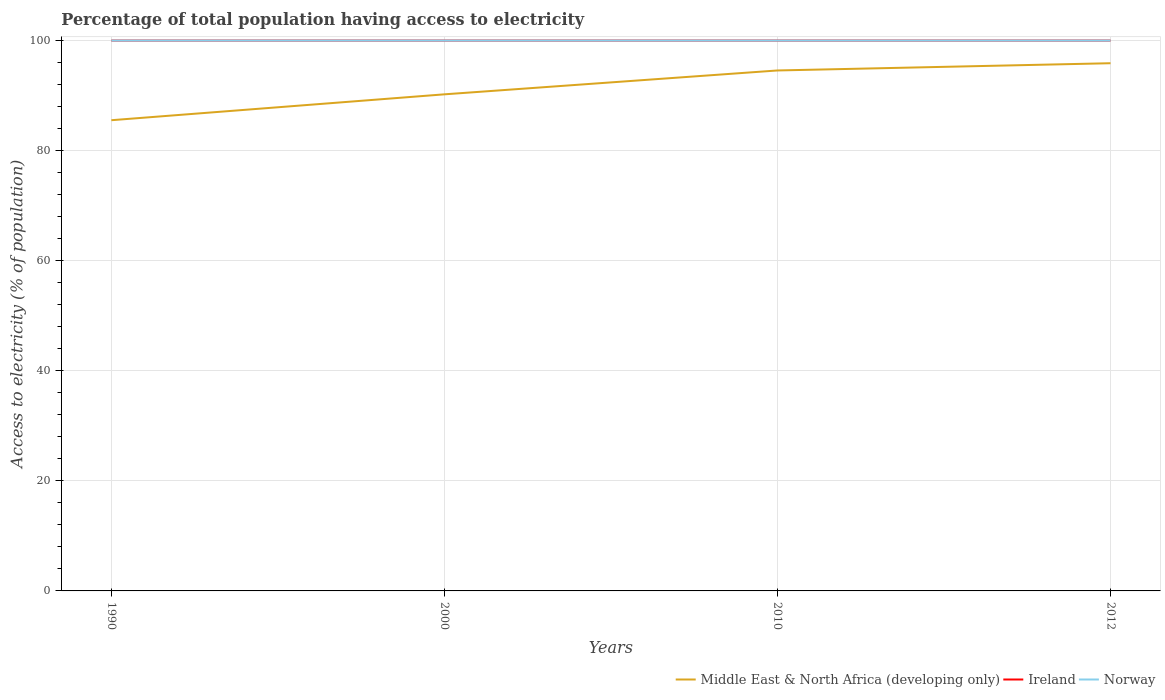How many different coloured lines are there?
Your response must be concise. 3. Does the line corresponding to Norway intersect with the line corresponding to Middle East & North Africa (developing only)?
Provide a short and direct response. No. Across all years, what is the maximum percentage of population that have access to electricity in Middle East & North Africa (developing only)?
Keep it short and to the point. 85.53. How many lines are there?
Your response must be concise. 3. What is the difference between two consecutive major ticks on the Y-axis?
Give a very brief answer. 20. Does the graph contain any zero values?
Your answer should be very brief. No. Where does the legend appear in the graph?
Your answer should be compact. Bottom right. How many legend labels are there?
Give a very brief answer. 3. How are the legend labels stacked?
Give a very brief answer. Horizontal. What is the title of the graph?
Give a very brief answer. Percentage of total population having access to electricity. What is the label or title of the Y-axis?
Offer a terse response. Access to electricity (% of population). What is the Access to electricity (% of population) of Middle East & North Africa (developing only) in 1990?
Provide a short and direct response. 85.53. What is the Access to electricity (% of population) in Norway in 1990?
Make the answer very short. 100. What is the Access to electricity (% of population) of Middle East & North Africa (developing only) in 2000?
Offer a very short reply. 90.23. What is the Access to electricity (% of population) in Ireland in 2000?
Offer a very short reply. 100. What is the Access to electricity (% of population) of Norway in 2000?
Make the answer very short. 100. What is the Access to electricity (% of population) in Middle East & North Africa (developing only) in 2010?
Provide a short and direct response. 94.57. What is the Access to electricity (% of population) in Norway in 2010?
Provide a short and direct response. 100. What is the Access to electricity (% of population) of Middle East & North Africa (developing only) in 2012?
Ensure brevity in your answer.  95.88. What is the Access to electricity (% of population) in Norway in 2012?
Provide a short and direct response. 100. Across all years, what is the maximum Access to electricity (% of population) in Middle East & North Africa (developing only)?
Your response must be concise. 95.88. Across all years, what is the minimum Access to electricity (% of population) of Middle East & North Africa (developing only)?
Offer a terse response. 85.53. What is the total Access to electricity (% of population) of Middle East & North Africa (developing only) in the graph?
Your response must be concise. 366.21. What is the total Access to electricity (% of population) of Ireland in the graph?
Give a very brief answer. 400. What is the total Access to electricity (% of population) of Norway in the graph?
Keep it short and to the point. 400. What is the difference between the Access to electricity (% of population) in Middle East & North Africa (developing only) in 1990 and that in 2000?
Provide a short and direct response. -4.7. What is the difference between the Access to electricity (% of population) in Norway in 1990 and that in 2000?
Your response must be concise. 0. What is the difference between the Access to electricity (% of population) of Middle East & North Africa (developing only) in 1990 and that in 2010?
Your response must be concise. -9.04. What is the difference between the Access to electricity (% of population) in Norway in 1990 and that in 2010?
Provide a short and direct response. 0. What is the difference between the Access to electricity (% of population) of Middle East & North Africa (developing only) in 1990 and that in 2012?
Your response must be concise. -10.36. What is the difference between the Access to electricity (% of population) in Middle East & North Africa (developing only) in 2000 and that in 2010?
Offer a very short reply. -4.34. What is the difference between the Access to electricity (% of population) of Ireland in 2000 and that in 2010?
Make the answer very short. 0. What is the difference between the Access to electricity (% of population) in Middle East & North Africa (developing only) in 2000 and that in 2012?
Your answer should be compact. -5.65. What is the difference between the Access to electricity (% of population) in Middle East & North Africa (developing only) in 2010 and that in 2012?
Offer a very short reply. -1.32. What is the difference between the Access to electricity (% of population) in Ireland in 2010 and that in 2012?
Your answer should be very brief. 0. What is the difference between the Access to electricity (% of population) in Middle East & North Africa (developing only) in 1990 and the Access to electricity (% of population) in Ireland in 2000?
Your answer should be compact. -14.47. What is the difference between the Access to electricity (% of population) of Middle East & North Africa (developing only) in 1990 and the Access to electricity (% of population) of Norway in 2000?
Keep it short and to the point. -14.47. What is the difference between the Access to electricity (% of population) of Middle East & North Africa (developing only) in 1990 and the Access to electricity (% of population) of Ireland in 2010?
Your answer should be very brief. -14.47. What is the difference between the Access to electricity (% of population) of Middle East & North Africa (developing only) in 1990 and the Access to electricity (% of population) of Norway in 2010?
Provide a short and direct response. -14.47. What is the difference between the Access to electricity (% of population) of Middle East & North Africa (developing only) in 1990 and the Access to electricity (% of population) of Ireland in 2012?
Your answer should be very brief. -14.47. What is the difference between the Access to electricity (% of population) of Middle East & North Africa (developing only) in 1990 and the Access to electricity (% of population) of Norway in 2012?
Make the answer very short. -14.47. What is the difference between the Access to electricity (% of population) in Middle East & North Africa (developing only) in 2000 and the Access to electricity (% of population) in Ireland in 2010?
Offer a terse response. -9.77. What is the difference between the Access to electricity (% of population) of Middle East & North Africa (developing only) in 2000 and the Access to electricity (% of population) of Norway in 2010?
Your answer should be compact. -9.77. What is the difference between the Access to electricity (% of population) in Ireland in 2000 and the Access to electricity (% of population) in Norway in 2010?
Ensure brevity in your answer.  0. What is the difference between the Access to electricity (% of population) of Middle East & North Africa (developing only) in 2000 and the Access to electricity (% of population) of Ireland in 2012?
Provide a short and direct response. -9.77. What is the difference between the Access to electricity (% of population) of Middle East & North Africa (developing only) in 2000 and the Access to electricity (% of population) of Norway in 2012?
Offer a terse response. -9.77. What is the difference between the Access to electricity (% of population) of Middle East & North Africa (developing only) in 2010 and the Access to electricity (% of population) of Ireland in 2012?
Provide a succinct answer. -5.43. What is the difference between the Access to electricity (% of population) in Middle East & North Africa (developing only) in 2010 and the Access to electricity (% of population) in Norway in 2012?
Make the answer very short. -5.43. What is the difference between the Access to electricity (% of population) in Ireland in 2010 and the Access to electricity (% of population) in Norway in 2012?
Ensure brevity in your answer.  0. What is the average Access to electricity (% of population) of Middle East & North Africa (developing only) per year?
Make the answer very short. 91.55. What is the average Access to electricity (% of population) in Norway per year?
Your answer should be very brief. 100. In the year 1990, what is the difference between the Access to electricity (% of population) of Middle East & North Africa (developing only) and Access to electricity (% of population) of Ireland?
Provide a succinct answer. -14.47. In the year 1990, what is the difference between the Access to electricity (% of population) of Middle East & North Africa (developing only) and Access to electricity (% of population) of Norway?
Make the answer very short. -14.47. In the year 1990, what is the difference between the Access to electricity (% of population) in Ireland and Access to electricity (% of population) in Norway?
Your answer should be compact. 0. In the year 2000, what is the difference between the Access to electricity (% of population) of Middle East & North Africa (developing only) and Access to electricity (% of population) of Ireland?
Give a very brief answer. -9.77. In the year 2000, what is the difference between the Access to electricity (% of population) in Middle East & North Africa (developing only) and Access to electricity (% of population) in Norway?
Your answer should be compact. -9.77. In the year 2000, what is the difference between the Access to electricity (% of population) in Ireland and Access to electricity (% of population) in Norway?
Give a very brief answer. 0. In the year 2010, what is the difference between the Access to electricity (% of population) in Middle East & North Africa (developing only) and Access to electricity (% of population) in Ireland?
Ensure brevity in your answer.  -5.43. In the year 2010, what is the difference between the Access to electricity (% of population) in Middle East & North Africa (developing only) and Access to electricity (% of population) in Norway?
Ensure brevity in your answer.  -5.43. In the year 2012, what is the difference between the Access to electricity (% of population) in Middle East & North Africa (developing only) and Access to electricity (% of population) in Ireland?
Your answer should be compact. -4.12. In the year 2012, what is the difference between the Access to electricity (% of population) in Middle East & North Africa (developing only) and Access to electricity (% of population) in Norway?
Ensure brevity in your answer.  -4.12. What is the ratio of the Access to electricity (% of population) in Middle East & North Africa (developing only) in 1990 to that in 2000?
Make the answer very short. 0.95. What is the ratio of the Access to electricity (% of population) of Ireland in 1990 to that in 2000?
Your answer should be compact. 1. What is the ratio of the Access to electricity (% of population) of Norway in 1990 to that in 2000?
Your response must be concise. 1. What is the ratio of the Access to electricity (% of population) in Middle East & North Africa (developing only) in 1990 to that in 2010?
Your answer should be very brief. 0.9. What is the ratio of the Access to electricity (% of population) of Ireland in 1990 to that in 2010?
Provide a succinct answer. 1. What is the ratio of the Access to electricity (% of population) in Middle East & North Africa (developing only) in 1990 to that in 2012?
Ensure brevity in your answer.  0.89. What is the ratio of the Access to electricity (% of population) in Middle East & North Africa (developing only) in 2000 to that in 2010?
Keep it short and to the point. 0.95. What is the ratio of the Access to electricity (% of population) of Middle East & North Africa (developing only) in 2000 to that in 2012?
Your response must be concise. 0.94. What is the ratio of the Access to electricity (% of population) of Ireland in 2000 to that in 2012?
Ensure brevity in your answer.  1. What is the ratio of the Access to electricity (% of population) of Middle East & North Africa (developing only) in 2010 to that in 2012?
Provide a succinct answer. 0.99. What is the ratio of the Access to electricity (% of population) in Ireland in 2010 to that in 2012?
Your answer should be very brief. 1. What is the ratio of the Access to electricity (% of population) in Norway in 2010 to that in 2012?
Your answer should be compact. 1. What is the difference between the highest and the second highest Access to electricity (% of population) of Middle East & North Africa (developing only)?
Ensure brevity in your answer.  1.32. What is the difference between the highest and the second highest Access to electricity (% of population) of Norway?
Provide a succinct answer. 0. What is the difference between the highest and the lowest Access to electricity (% of population) in Middle East & North Africa (developing only)?
Provide a short and direct response. 10.36. What is the difference between the highest and the lowest Access to electricity (% of population) in Ireland?
Offer a terse response. 0. 